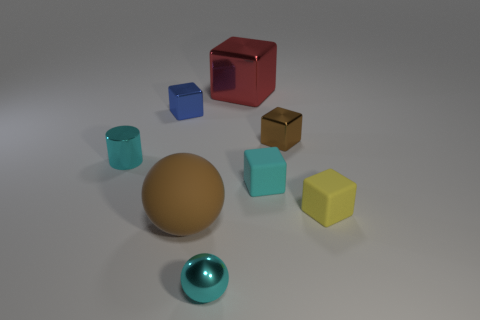Is there a blue block made of the same material as the small ball?
Your response must be concise. Yes. How many tiny shiny blocks are there?
Provide a succinct answer. 2. Does the tiny blue object have the same material as the large thing that is to the left of the big shiny block?
Your response must be concise. No. There is a ball that is the same color as the cylinder; what is it made of?
Keep it short and to the point. Metal. How many big things have the same color as the large block?
Keep it short and to the point. 0. The cyan ball is what size?
Your response must be concise. Small. Is the shape of the red metal object the same as the cyan metallic thing that is left of the cyan sphere?
Your answer should be very brief. No. There is a small ball that is made of the same material as the small brown cube; what color is it?
Provide a short and direct response. Cyan. What is the size of the cyan object to the right of the red block?
Offer a very short reply. Small. Is the number of small brown things on the right side of the yellow thing less than the number of large blue shiny things?
Keep it short and to the point. No. 